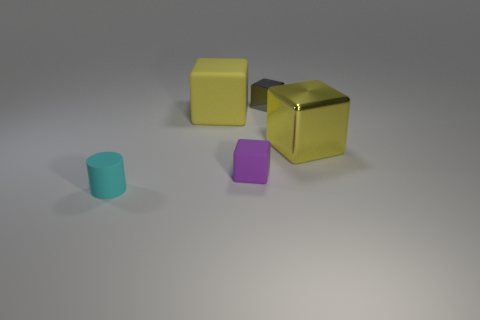Subtract all yellow blocks. How many were subtracted if there are1yellow blocks left? 1 Subtract all cubes. How many objects are left? 1 Subtract 1 cylinders. How many cylinders are left? 0 Subtract all green cylinders. Subtract all purple cubes. How many cylinders are left? 1 Subtract all purple spheres. How many gray cubes are left? 1 Subtract all large yellow matte objects. Subtract all yellow cubes. How many objects are left? 2 Add 5 gray shiny cubes. How many gray shiny cubes are left? 6 Add 1 small blue cubes. How many small blue cubes exist? 1 Add 3 small gray shiny cubes. How many objects exist? 8 Subtract all purple blocks. How many blocks are left? 3 